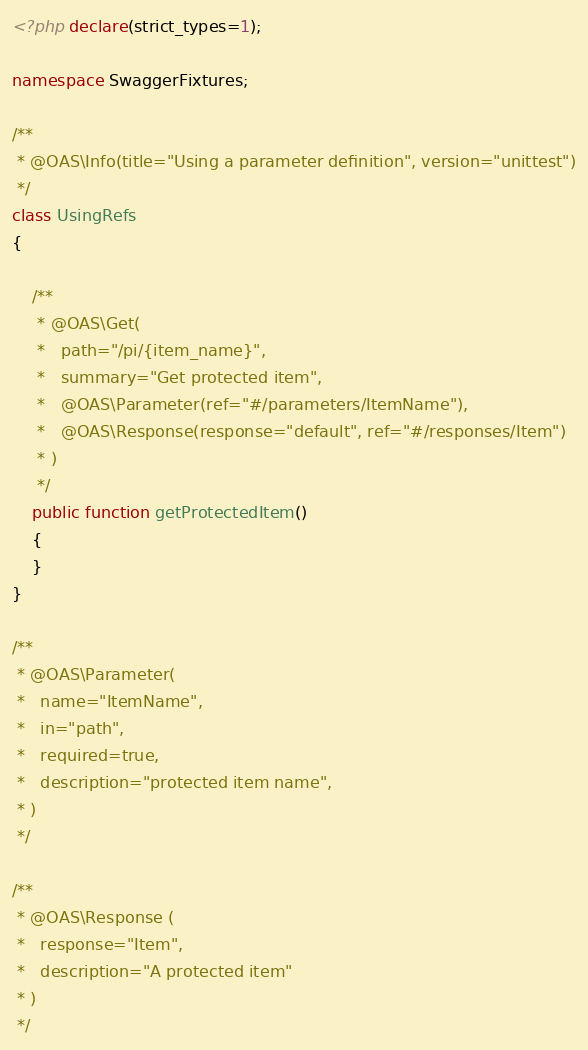Convert code to text. <code><loc_0><loc_0><loc_500><loc_500><_PHP_><?php declare(strict_types=1);

namespace SwaggerFixtures;

/**
 * @OAS\Info(title="Using a parameter definition", version="unittest")
 */
class UsingRefs
{

    /**
     * @OAS\Get(
     *   path="/pi/{item_name}",
     *   summary="Get protected item",
     *   @OAS\Parameter(ref="#/parameters/ItemName"),
     *   @OAS\Response(response="default", ref="#/responses/Item")
     * )
     */
    public function getProtectedItem()
    {
    }
}

/**
 * @OAS\Parameter(
 *   name="ItemName",
 *   in="path",
 *   required=true,
 *   description="protected item name",
 * )
 */

/**
 * @OAS\Response (
 *   response="Item",
 *   description="A protected item"
 * )
 */
</code> 